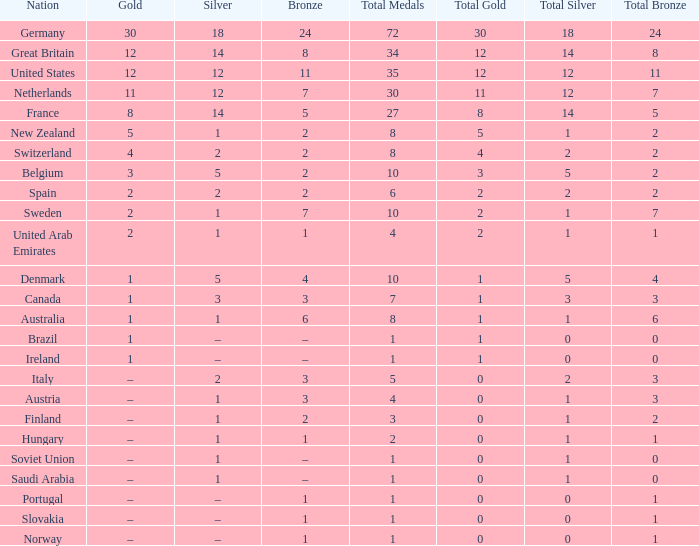What is gold, when silver amounts to 5, and when nation refers to belgium? 3.0. 